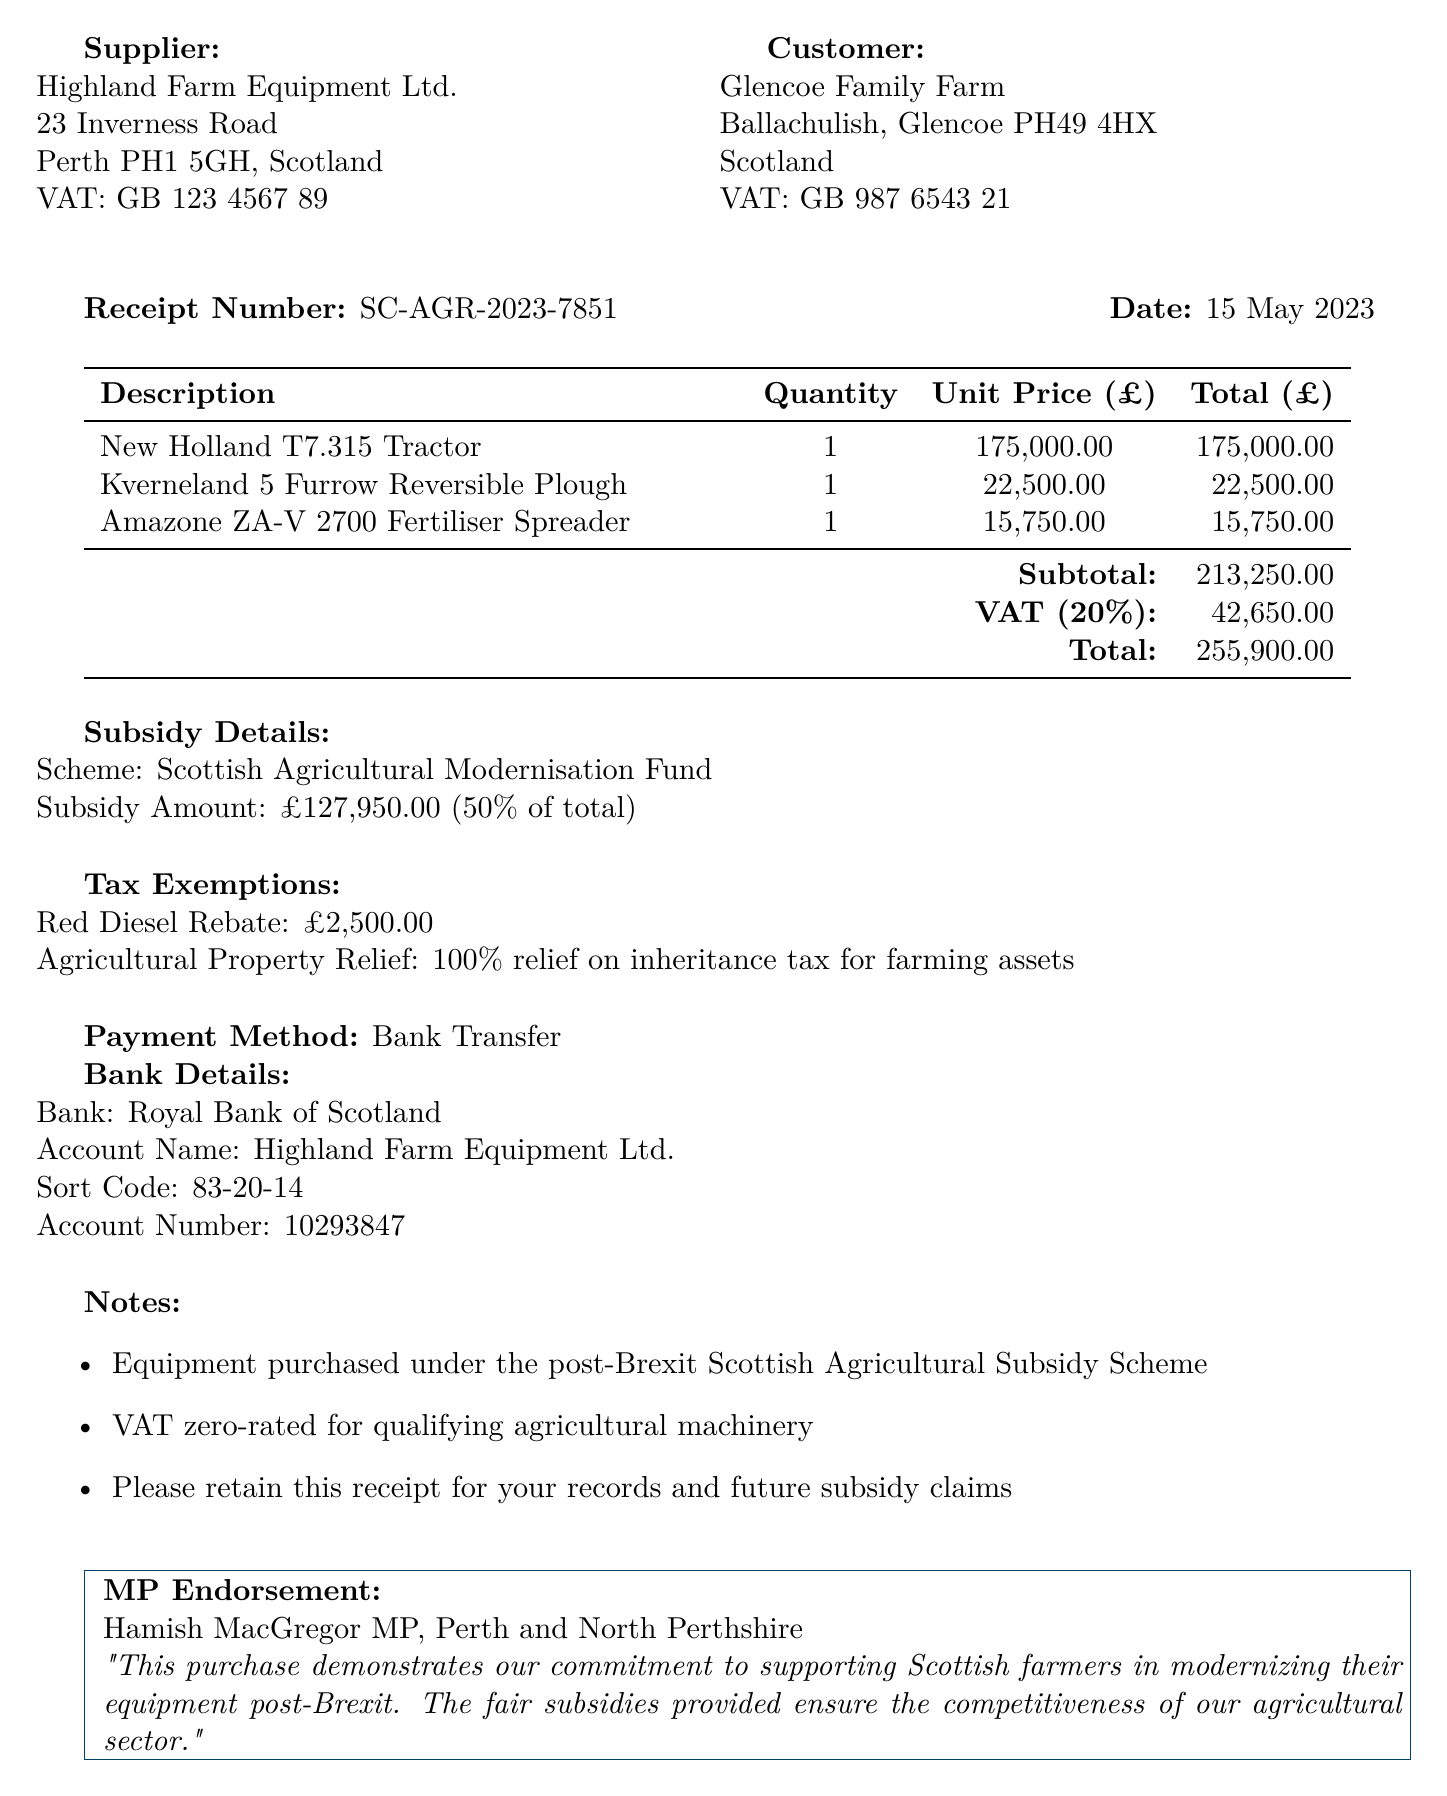What is the supplier's name? The supplier's name is mentioned in the document as Highland Farm Equipment Ltd.
Answer: Highland Farm Equipment Ltd What is the total amount due on the receipt? The total amount is stated as £255,900.00 in the document.
Answer: £255,900.00 When was the equipment purchased? The date of the receipt shows the purchase was made on 15 May 2023.
Answer: 15 May 2023 What is the subsidy percentage provided? The percentage of the subsidy is indicated as 50% for the equipment purchase.
Answer: 50% What type of relief is mentioned for agricultural property? The document mentions Agricultural Property Relief, which is 100% relief on inheritance tax for farming assets.
Answer: 100% relief on inheritance tax for farming assets How much was the subsidy amount received? The subsidy amount specified in the document is £127,950.00.
Answer: £127,950.00 What is the payment method used for this purchase? The payment method is indicated as Bank Transfer in the receipt.
Answer: Bank Transfer Which bank is associated with the payment? The bank mentioned in the details is the Royal Bank of Scotland.
Answer: Royal Bank of Scotland What does the MP endorsement highlight about the purchase? The endorsement emphasizes commitment to supporting Scottish farmers and modernizing their equipment post-Brexit.
Answer: Supporting Scottish farmers and modernizing their equipment post-Brexit 